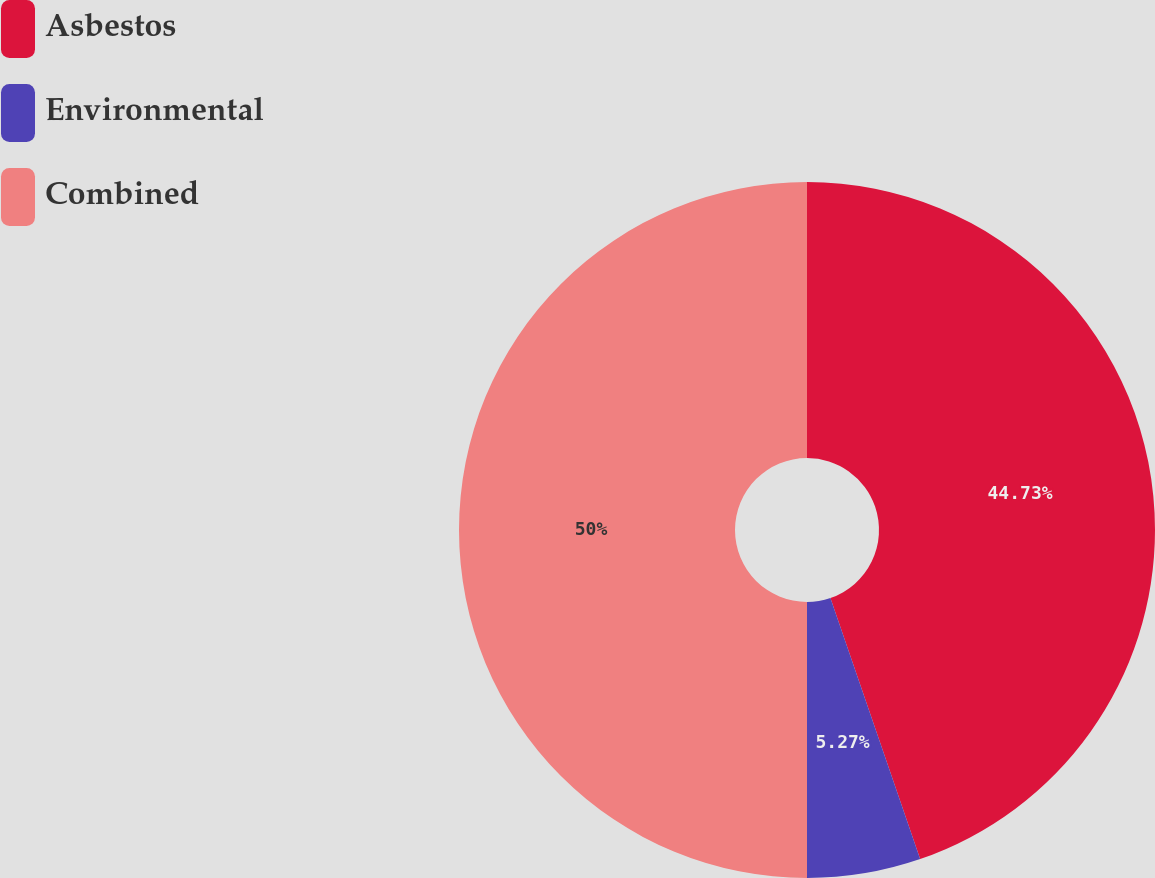Convert chart to OTSL. <chart><loc_0><loc_0><loc_500><loc_500><pie_chart><fcel>Asbestos<fcel>Environmental<fcel>Combined<nl><fcel>44.73%<fcel>5.27%<fcel>50.0%<nl></chart> 